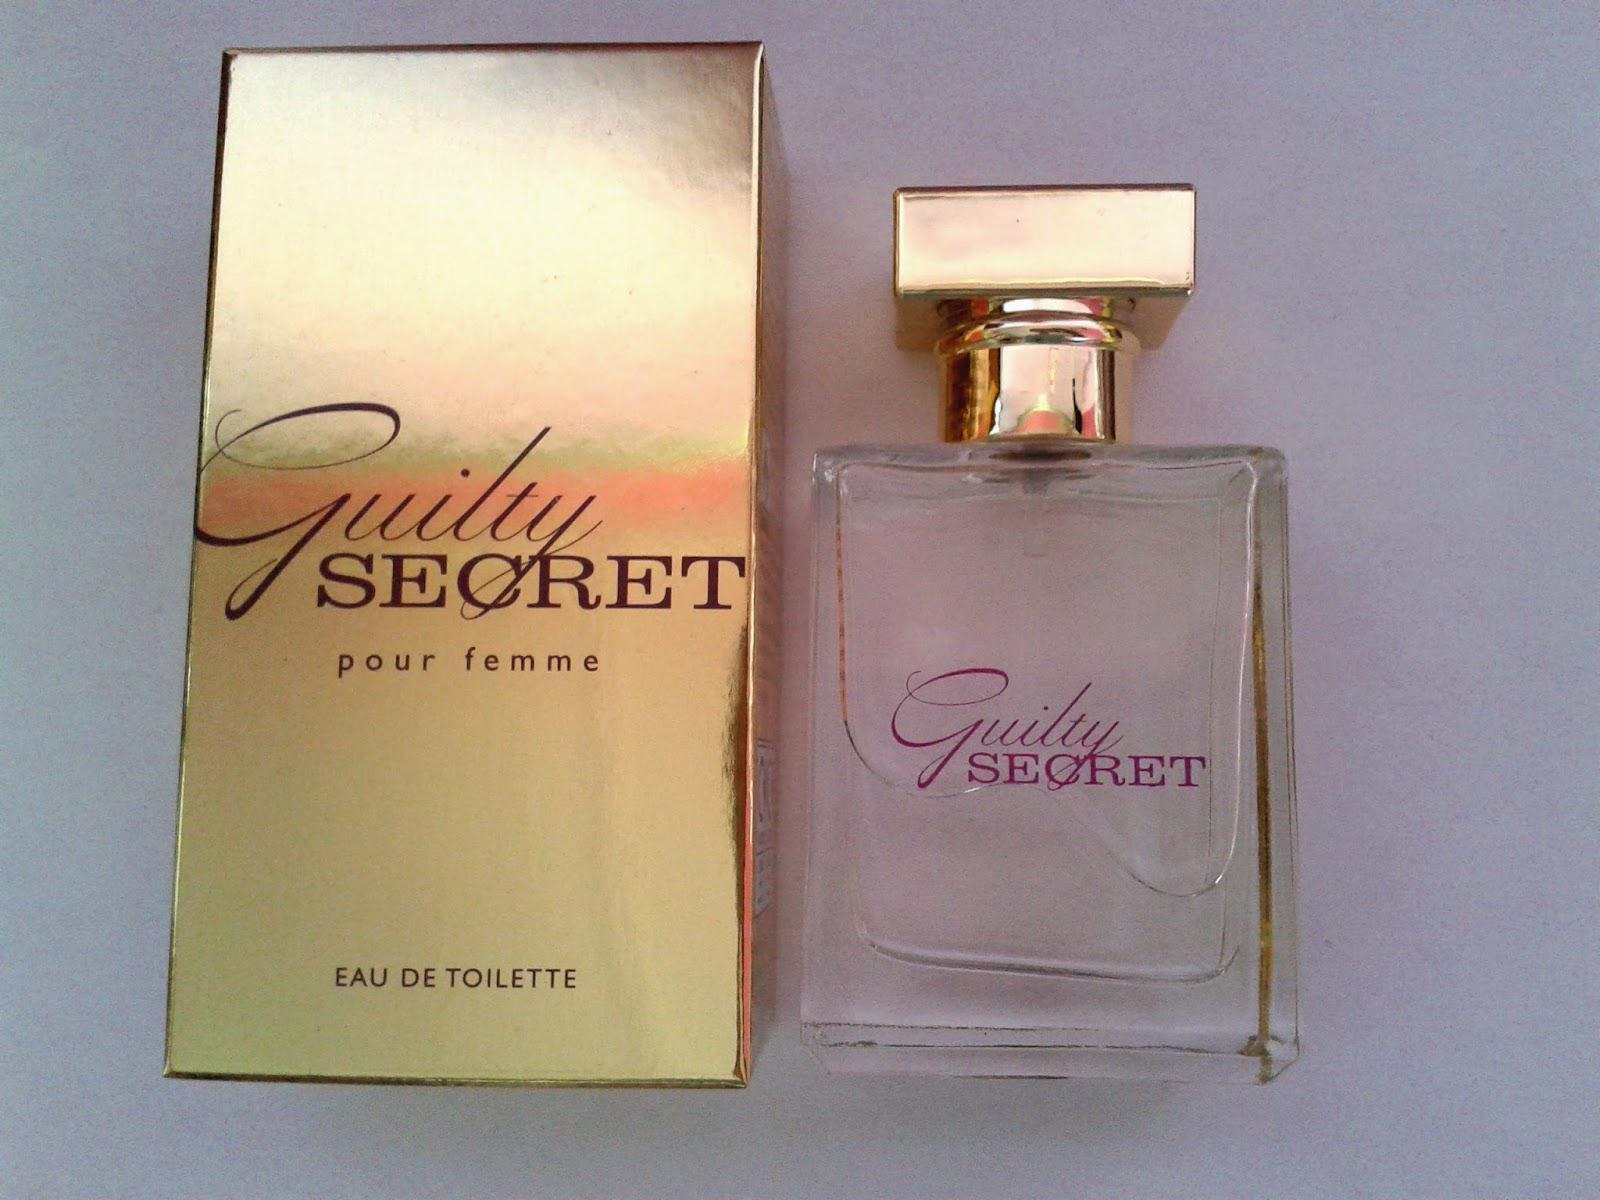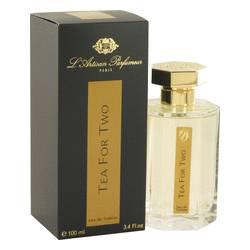The first image is the image on the left, the second image is the image on the right. Assess this claim about the two images: "Each image shows two cologne products, at least one of which is a bottle of yellowish liquid with a square lid.". Correct or not? Answer yes or no. No. The first image is the image on the left, the second image is the image on the right. Analyze the images presented: Is the assertion "An image shows one square-bottled fragrance on the right side of its gold box, and not overlapping the box." valid? Answer yes or no. Yes. 